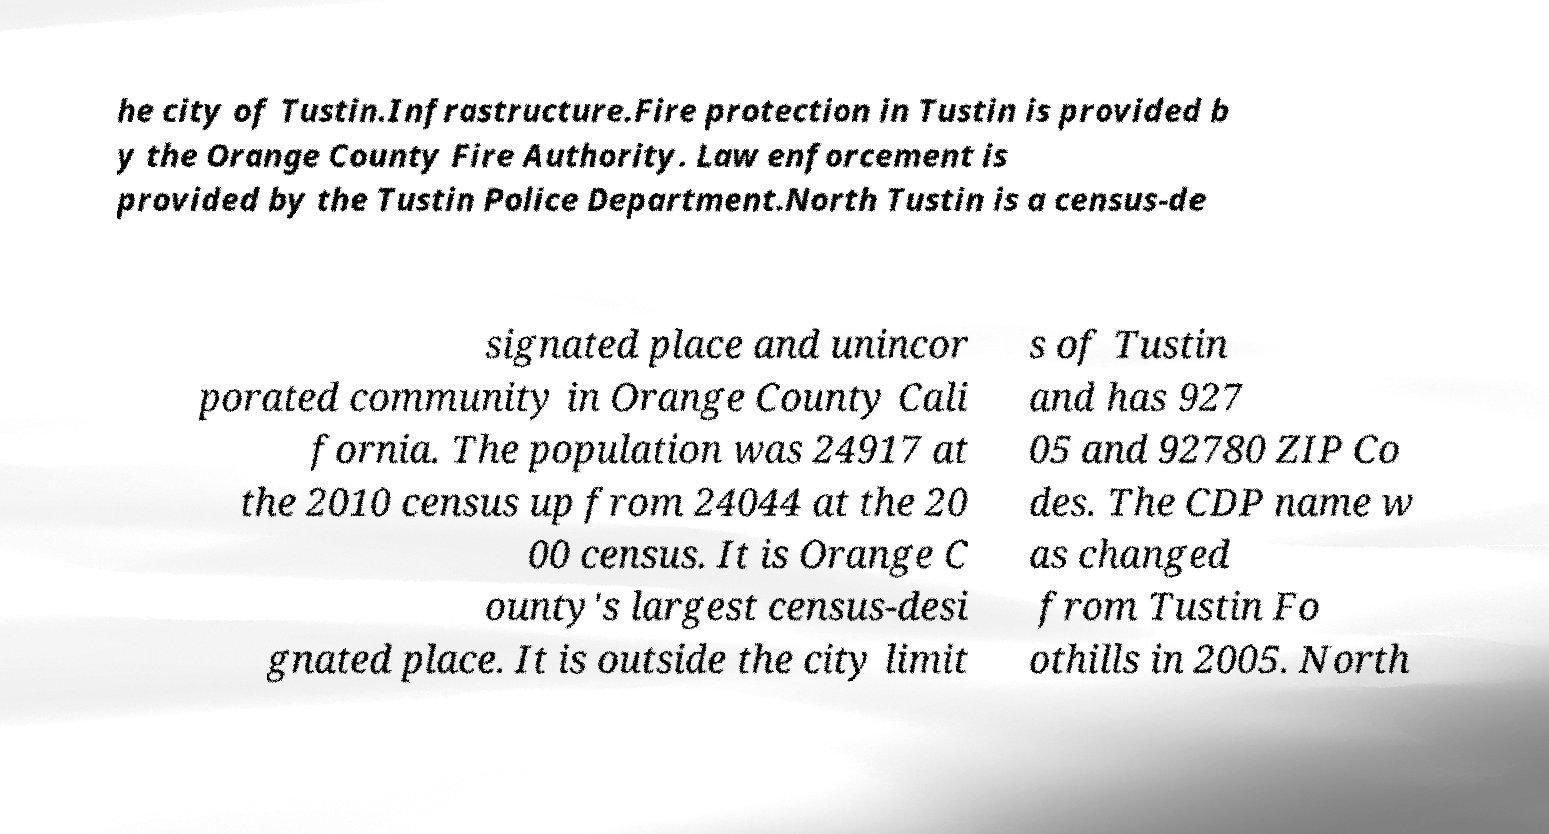I need the written content from this picture converted into text. Can you do that? he city of Tustin.Infrastructure.Fire protection in Tustin is provided b y the Orange County Fire Authority. Law enforcement is provided by the Tustin Police Department.North Tustin is a census-de signated place and unincor porated community in Orange County Cali fornia. The population was 24917 at the 2010 census up from 24044 at the 20 00 census. It is Orange C ounty's largest census-desi gnated place. It is outside the city limit s of Tustin and has 927 05 and 92780 ZIP Co des. The CDP name w as changed from Tustin Fo othills in 2005. North 